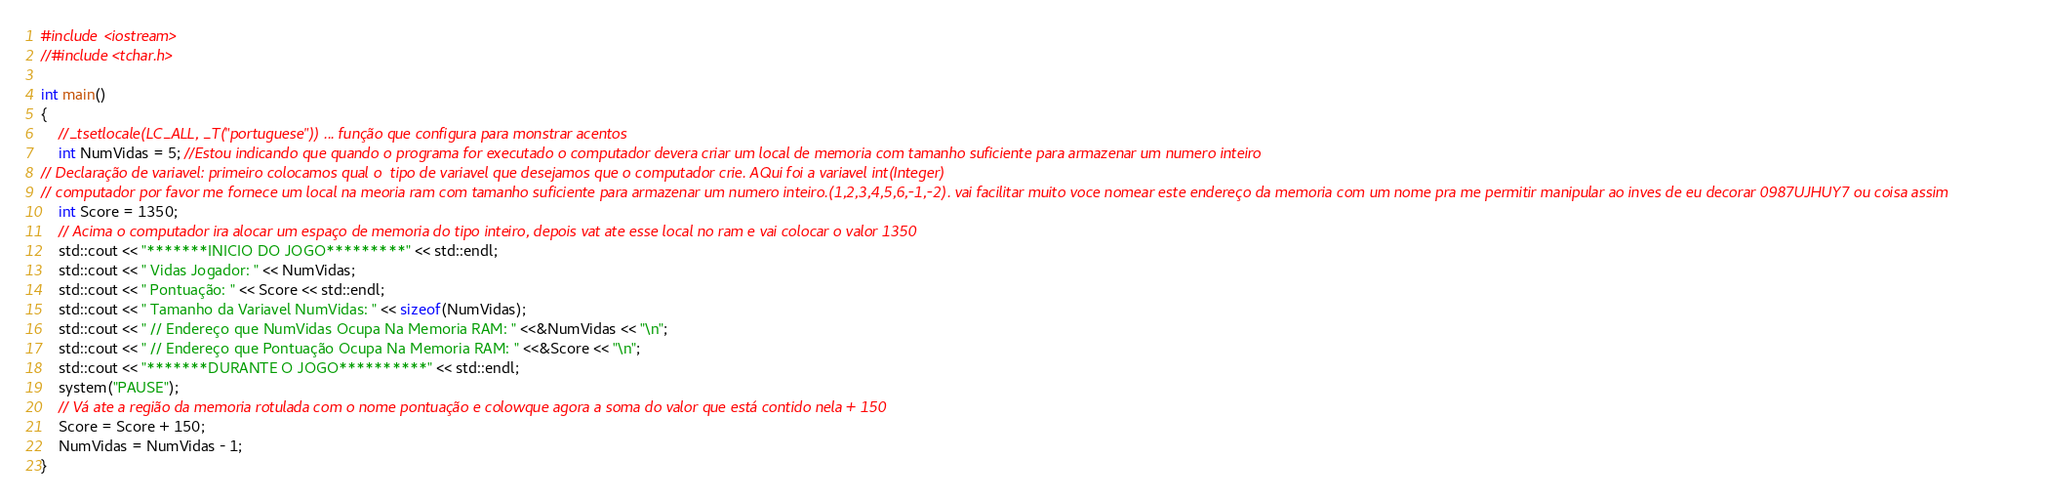<code> <loc_0><loc_0><loc_500><loc_500><_C++_>#include <iostream>
//#include <tchar.h>

int main()
{
    //_tsetlocale(LC_ALL, _T("portuguese")) ... função que configura para monstrar acentos
    int NumVidas = 5; //Estou indicando que quando o programa for executado o computador devera criar um local de memoria com tamanho suficiente para armazenar um numero inteiro
// Declaração de variavel: primeiro colocamos qual o  tipo de variavel que desejamos que o computador crie. AQui foi a variavel int(Integer)
// computador por favor me fornece um local na meoria ram com tamanho suficiente para armazenar um numero inteiro.(1,2,3,4,5,6,-1,-2). vai facilitar muito voce nomear este endereço da memoria com um nome pra me permitir manipular ao inves de eu decorar 0987UJHUY7 ou coisa assim
    int Score = 1350;
    // Acima o computador ira alocar um espaço de memoria do tipo inteiro, depois vat ate esse local no ram e vai colocar o valor 1350
    std::cout << "*******INICIO DO JOGO*********" << std::endl;
    std::cout << " Vidas Jogador: " << NumVidas;
    std::cout << " Pontuação: " << Score << std::endl;
    std::cout << " Tamanho da Variavel NumVidas: " << sizeof(NumVidas);
    std::cout << " // Endereço que NumVidas Ocupa Na Memoria RAM: " <<&NumVidas << "\n";
    std::cout << " // Endereço que Pontuação Ocupa Na Memoria RAM: " <<&Score << "\n";
    std::cout << "*******DURANTE O JOGO**********" << std::endl;
    system("PAUSE");
    // Vá ate a região da memoria rotulada com o nome pontuação e colowque agora a soma do valor que está contido nela + 150
    Score = Score + 150;
    NumVidas = NumVidas - 1;
}</code> 